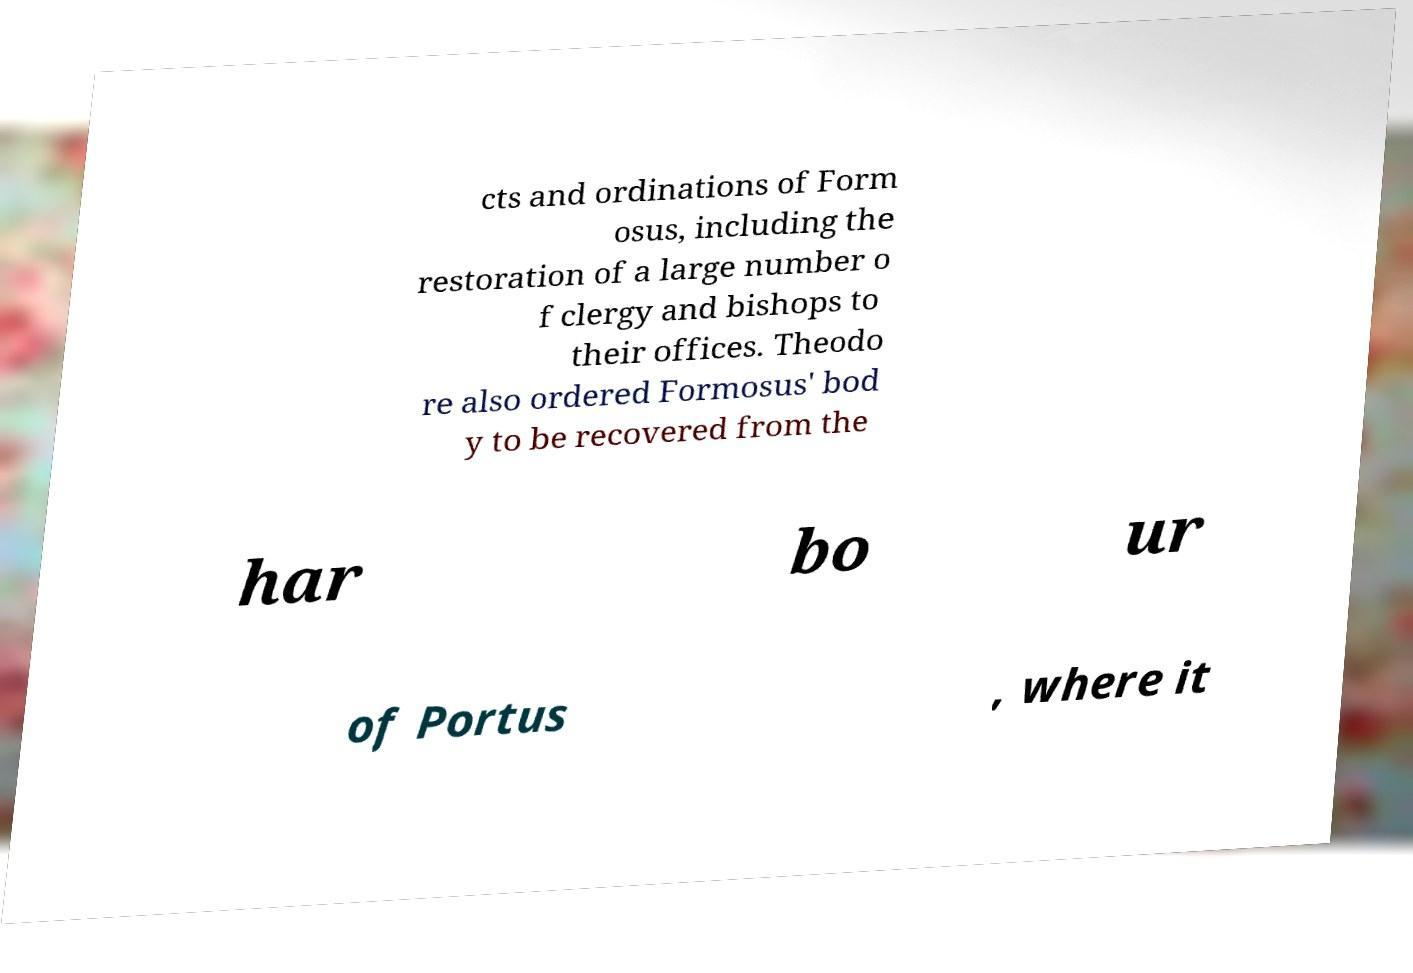Could you extract and type out the text from this image? cts and ordinations of Form osus, including the restoration of a large number o f clergy and bishops to their offices. Theodo re also ordered Formosus' bod y to be recovered from the har bo ur of Portus , where it 